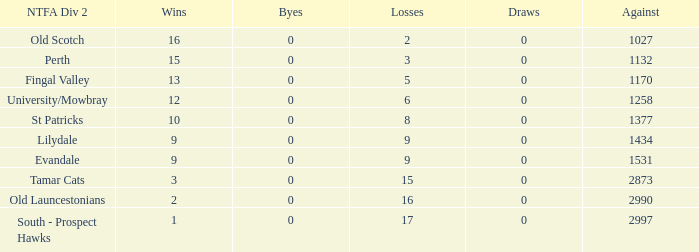What is the minimum number of opposition points in ntfa div 2 fingal valley? 1170.0. 